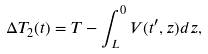<formula> <loc_0><loc_0><loc_500><loc_500>\Delta T _ { 2 } ( t ) = T - \int _ { L } ^ { 0 } V ( t ^ { \prime } , z ) d z ,</formula> 